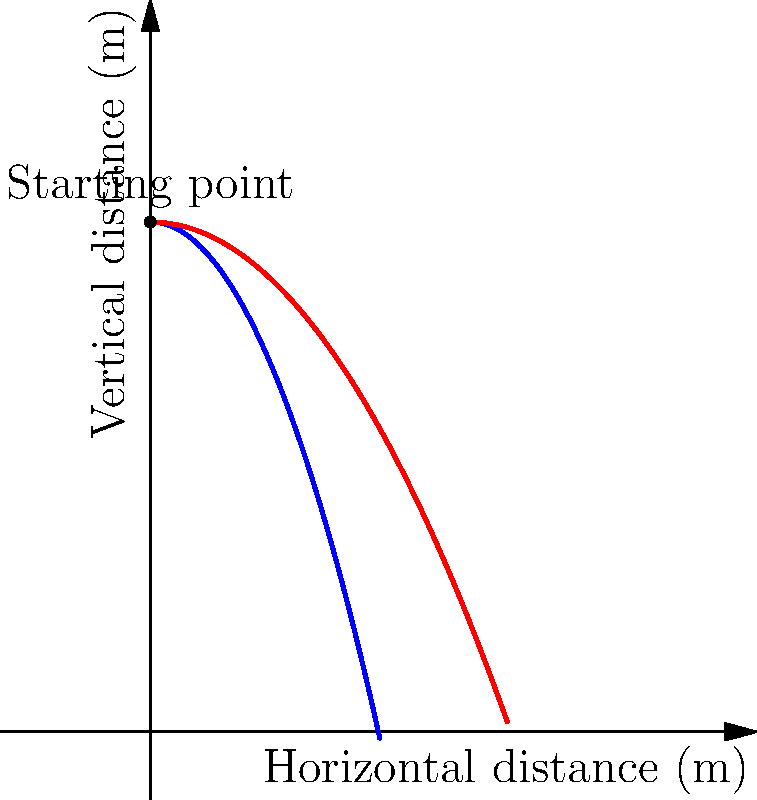During your morning walk in the professor's garden, you observe a leaf falling from a tree. Considering the effects of air resistance, which curve in the diagram best represents the leaf's trajectory, and how does it differ from the trajectory without air resistance? To answer this question, let's analyze the diagram and consider the physics of falling objects:

1. The blue curve represents the trajectory without air resistance, which is a perfect parabola.
2. The red curve represents the trajectory with air resistance, which is more realistic for a falling leaf.

3. Without air resistance:
   - The leaf would follow a parabolic path (blue curve).
   - It would fall faster and travel a shorter horizontal distance.

4. With air resistance (red curve):
   - The leaf experiences a drag force opposing its motion.
   - This force increases with velocity, eventually reaching terminal velocity.
   - The trajectory is more elongated horizontally.
   - The vertical descent is slower compared to the no-resistance case.

5. For a leaf:
   - Its large surface area relative to its mass makes air resistance significant.
   - It may even flutter or spiral down, further increasing air resistance.

6. The red curve better represents the leaf's likely path because:
   - It shows a more gradual descent.
   - It indicates a longer time in the air.
   - It demonstrates a greater horizontal distance traveled.

Therefore, the red curve best represents the leaf's trajectory, differing from the no-resistance case by showing a slower descent and greater horizontal displacement.
Answer: The red curve; slower descent and greater horizontal displacement due to air resistance. 